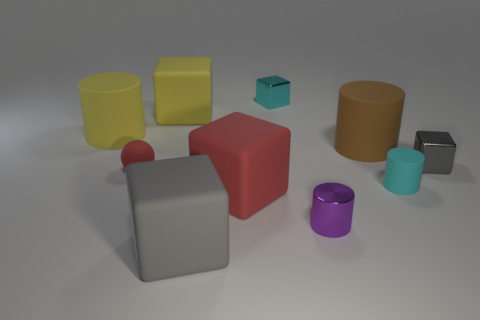What size is the rubber block that is the same color as the matte sphere?
Provide a short and direct response. Large. What is the material of the object that is the same color as the sphere?
Keep it short and to the point. Rubber. What number of matte objects are either small gray things or big yellow cubes?
Your answer should be compact. 1. What number of other things are there of the same shape as the tiny gray thing?
Your answer should be very brief. 4. Are there more things than red matte spheres?
Give a very brief answer. Yes. There is a rubber sphere in front of the small cyan thing behind the large matte cylinder that is on the right side of the small matte sphere; what size is it?
Offer a terse response. Small. How big is the gray block that is in front of the big red matte thing?
Offer a very short reply. Large. What number of things are tiny green matte cubes or large matte cylinders that are in front of the yellow cylinder?
Your response must be concise. 1. What number of other objects are there of the same size as the gray rubber thing?
Keep it short and to the point. 4. What is the material of the big yellow object that is the same shape as the tiny purple thing?
Your answer should be compact. Rubber. 